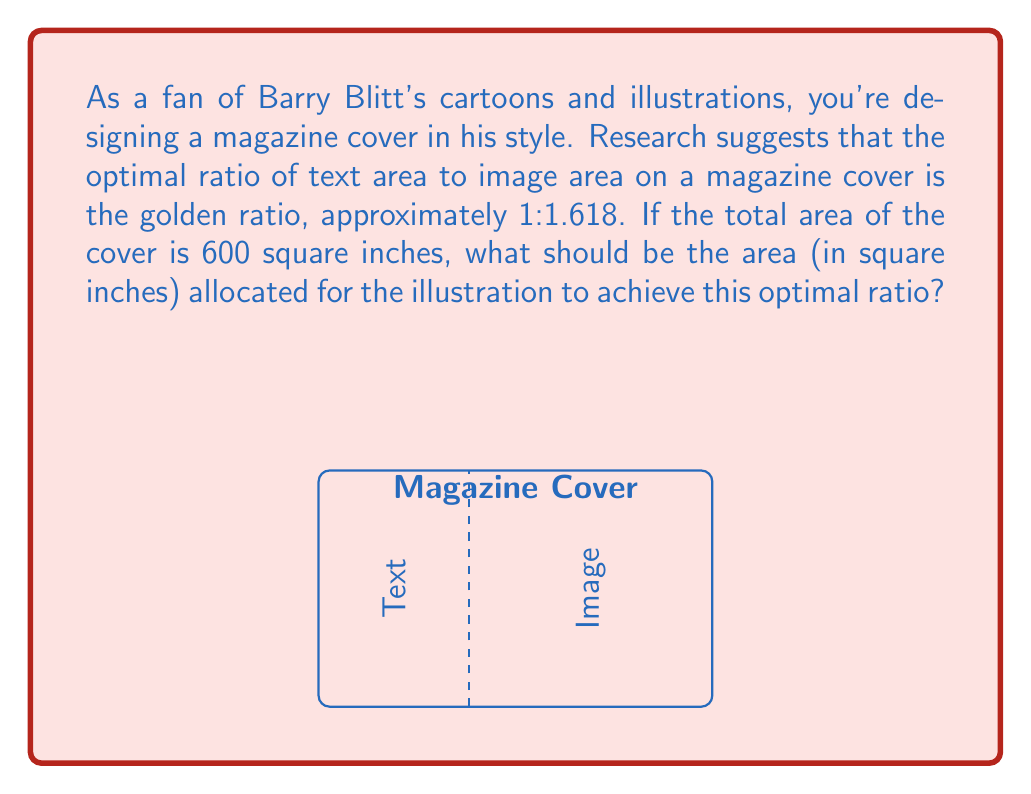Can you solve this math problem? Let's approach this step-by-step:

1) Let $x$ be the area of the text, and $y$ be the area of the image.

2) We know that the total area is 600 square inches:
   
   $$x + y = 600$$

3) The golden ratio states that:
   
   $$\frac{y}{x} = 1.618$$

4) We can rewrite this as:
   
   $$y = 1.618x$$

5) Substituting this into our first equation:
   
   $$x + 1.618x = 600$$
   $$2.618x = 600$$

6) Solving for $x$:
   
   $$x = \frac{600}{2.618} \approx 229.18$$

7) Since we want the area of the illustration (y), we can subtract this from the total area:
   
   $$y = 600 - 229.18 = 370.82$$

Therefore, the area allocated for the illustration should be approximately 370.82 square inches.
Answer: 370.82 square inches 